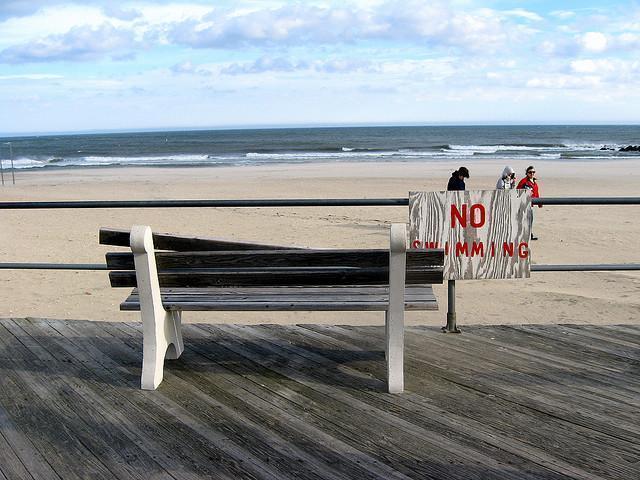What activity does the posted sign advise is not allowed?
Pick the correct solution from the four options below to address the question.
Options: Diving, biking, fishing, swimming. Swimming. 